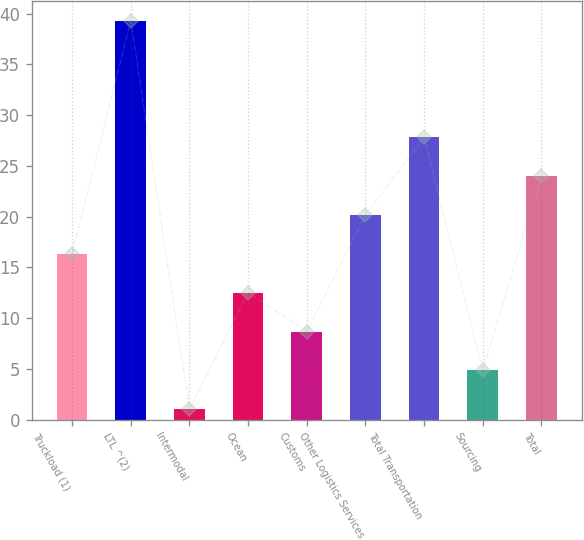<chart> <loc_0><loc_0><loc_500><loc_500><bar_chart><fcel>Truckload (1)<fcel>LTL ^(2)<fcel>Intermodal<fcel>Ocean<fcel>Customs<fcel>Other Logistics Services<fcel>Total Transportation<fcel>Sourcing<fcel>Total<nl><fcel>16.32<fcel>39.3<fcel>1<fcel>12.49<fcel>8.66<fcel>20.15<fcel>27.81<fcel>4.83<fcel>23.98<nl></chart> 